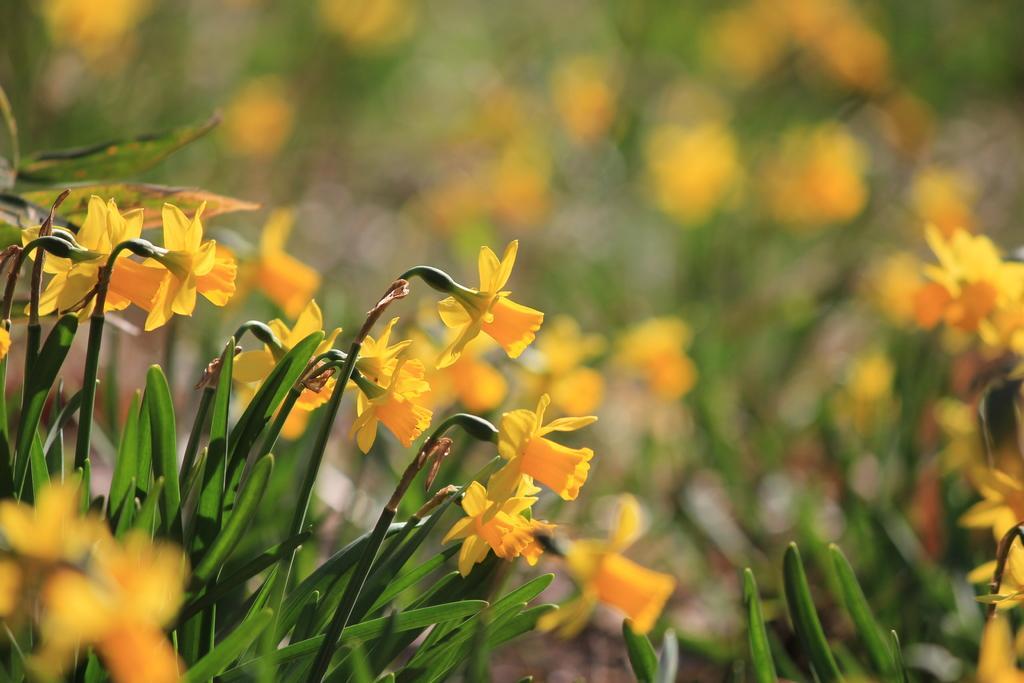Please provide a concise description of this image. In the image we can see there are yellow colour flowers on the plants and background of the image is blurred. 